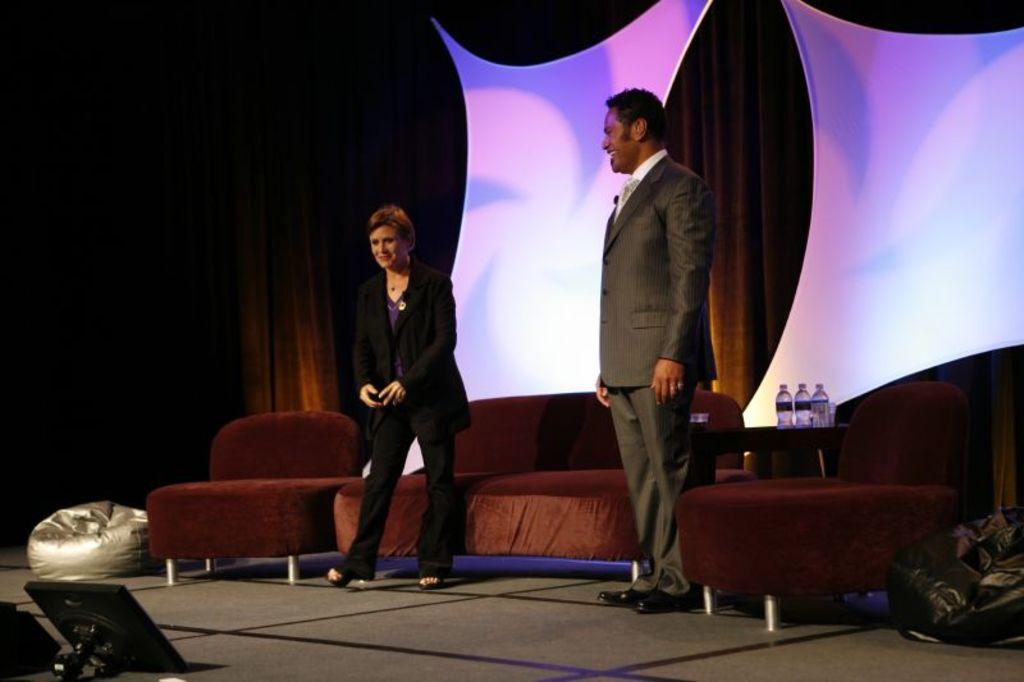How many people are in the image? There are two persons in the image. What piece of furniture is present in the image? There is a couch in the image. What objects can be seen on the table in the image? There are bottles on a table in the image. What type of bridge can be seen in the image? There is no bridge present in the image. What kind of test is being conducted in the image? There is no test being conducted in the image. 